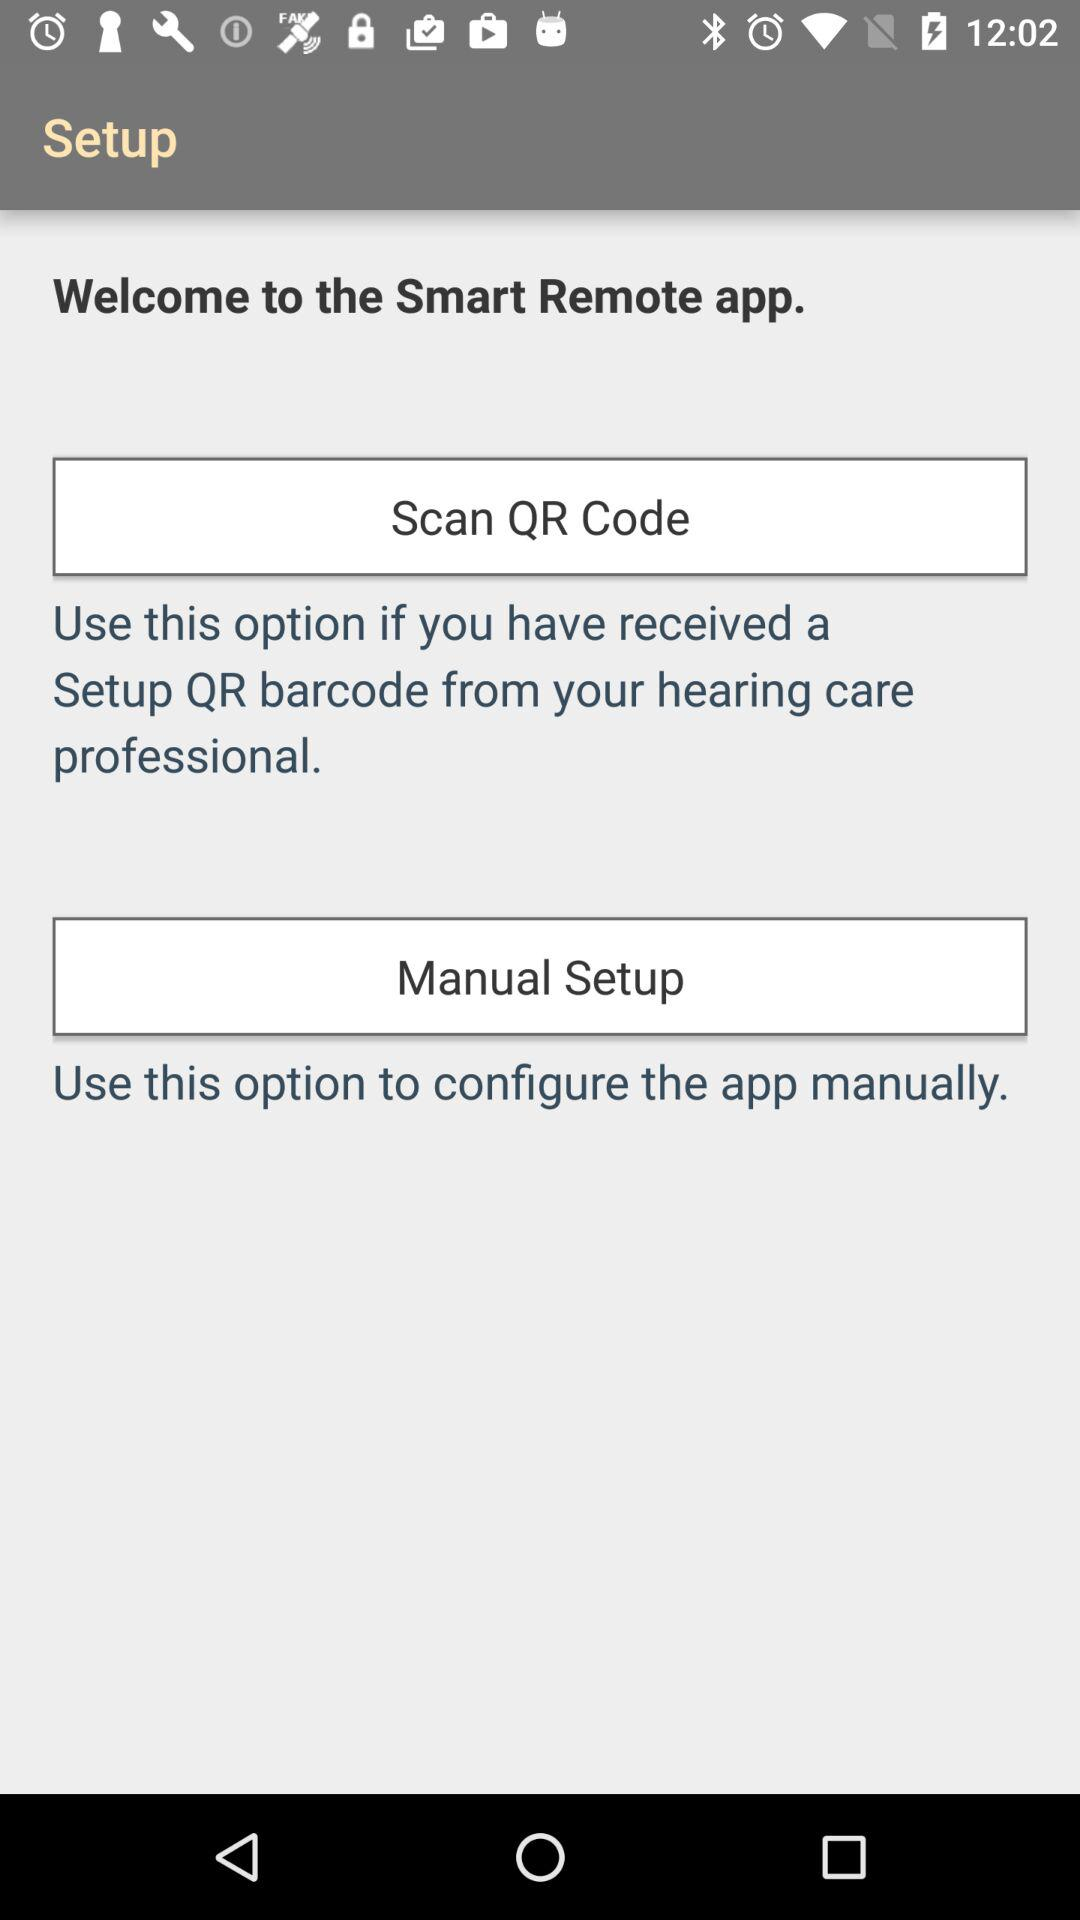When to use "Scan QR Code" option? The "Scan QR Code" option can be used if you have received a setup QR barcode from your hearing care professional. 